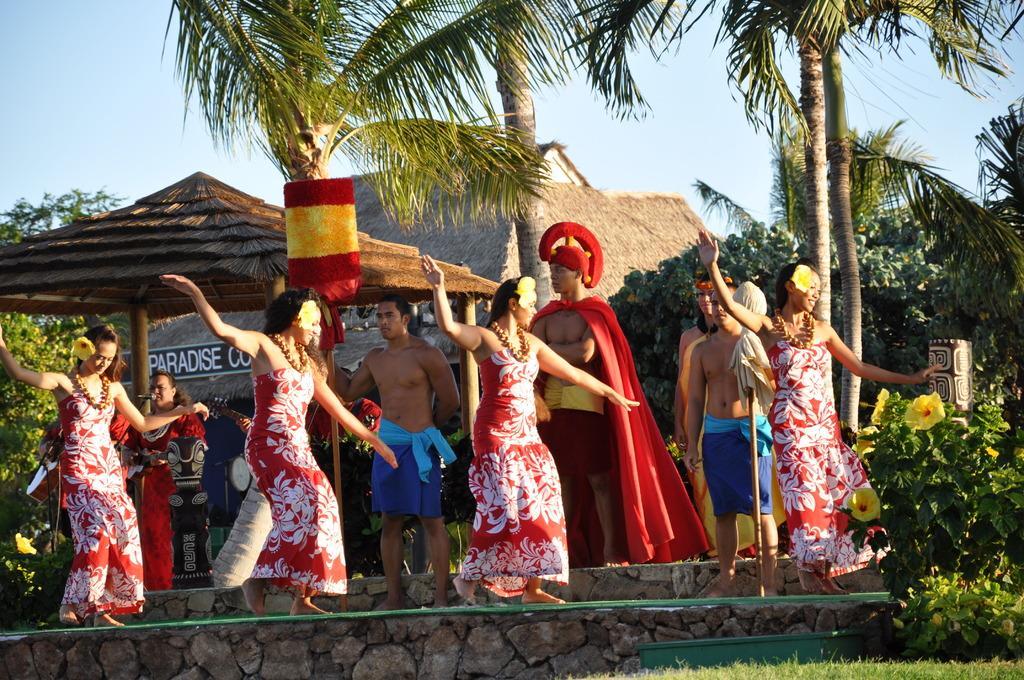Please provide a concise description of this image. In this image, we can see some ladies walking on rope and in the background, there are trees, huts, plants and some other people standing. 